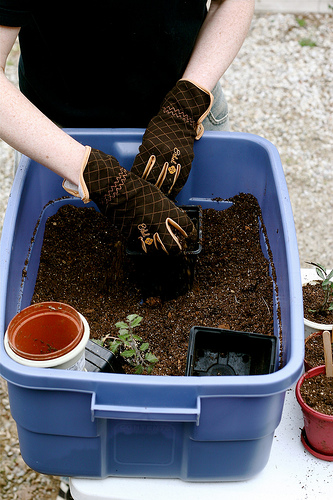<image>
Is the plant in the dirt? Yes. The plant is contained within or inside the dirt, showing a containment relationship. 